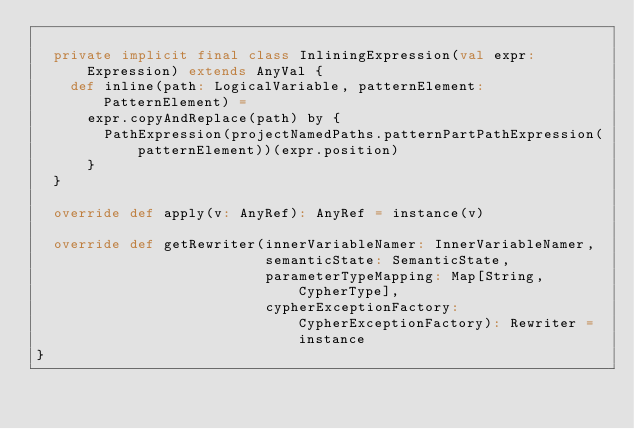<code> <loc_0><loc_0><loc_500><loc_500><_Scala_>
  private implicit final class InliningExpression(val expr: Expression) extends AnyVal {
    def inline(path: LogicalVariable, patternElement: PatternElement) =
      expr.copyAndReplace(path) by {
        PathExpression(projectNamedPaths.patternPartPathExpression(patternElement))(expr.position)
      }
  }

  override def apply(v: AnyRef): AnyRef = instance(v)

  override def getRewriter(innerVariableNamer: InnerVariableNamer,
                           semanticState: SemanticState,
                           parameterTypeMapping: Map[String, CypherType],
                           cypherExceptionFactory: CypherExceptionFactory): Rewriter = instance
}
</code> 